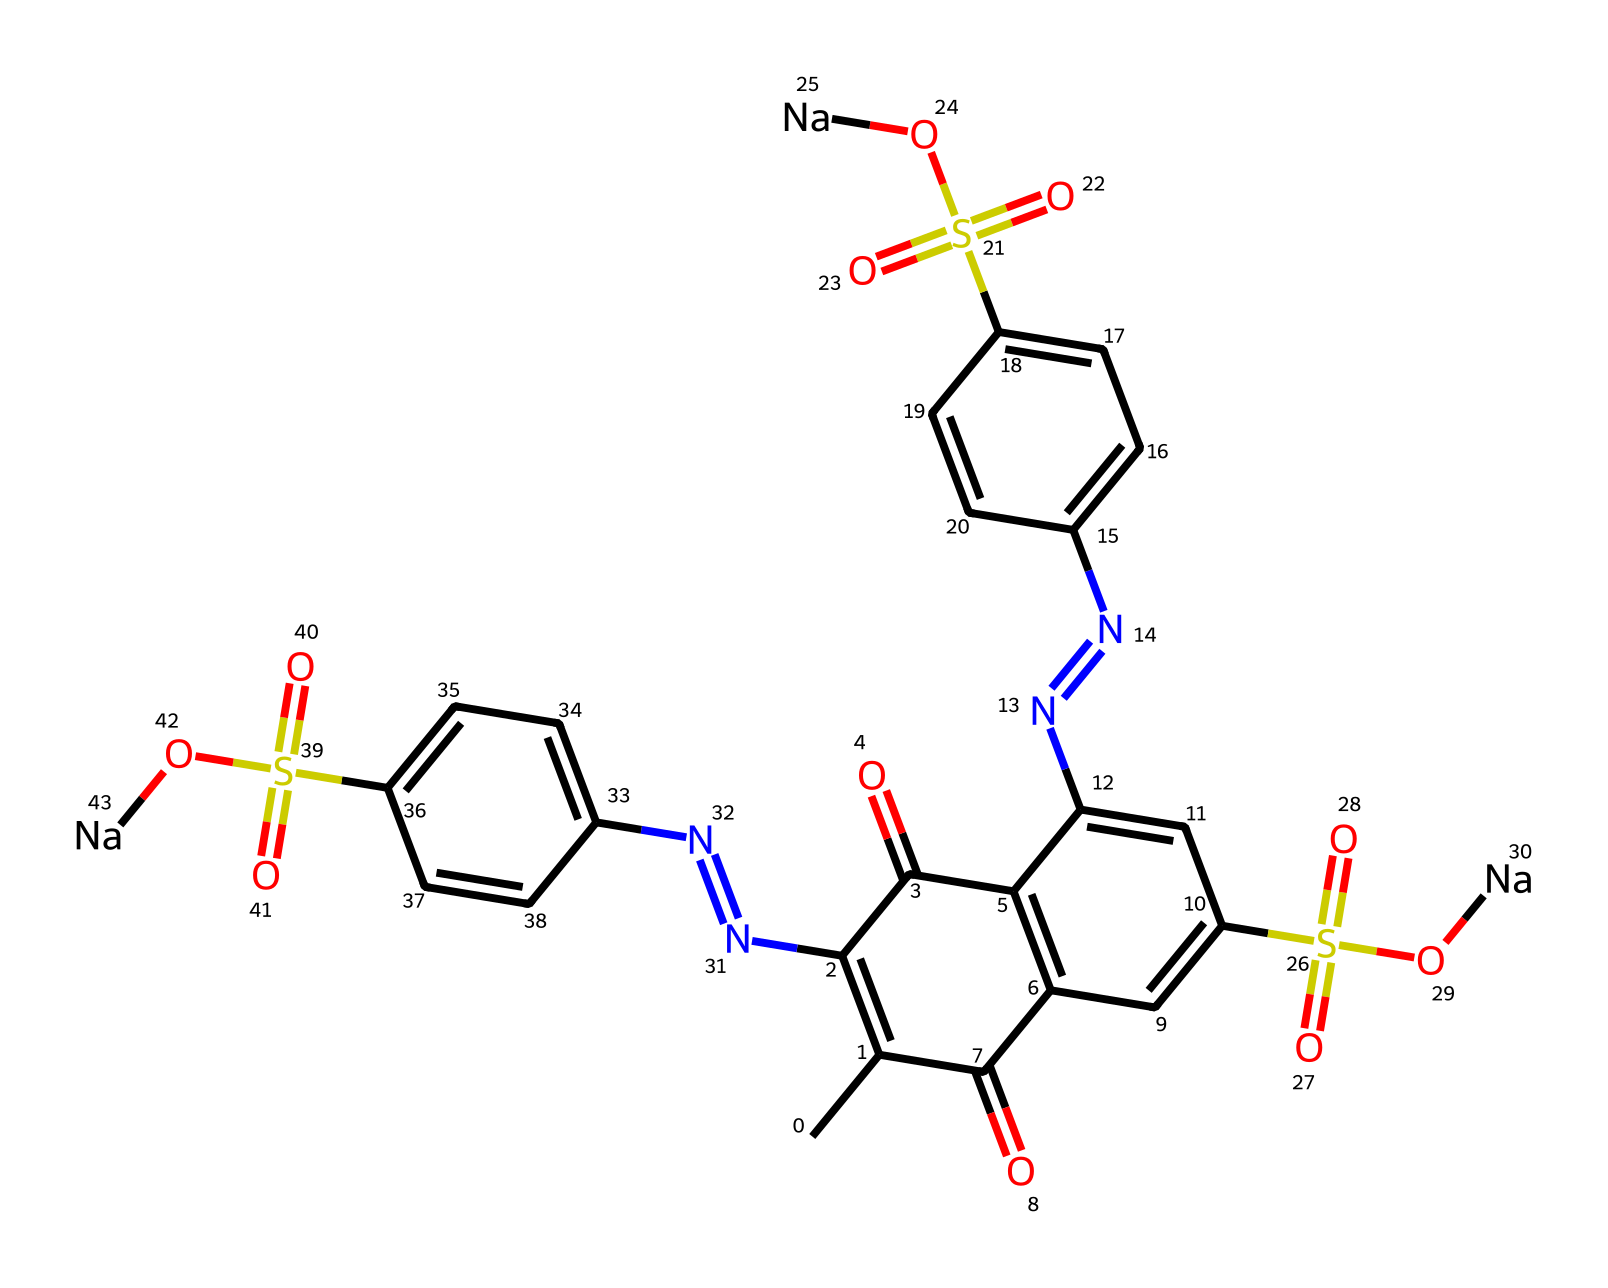What is the total number of carbon atoms in this chemical? By analyzing the SMILES representation, we identify that the structure contains 18 carbon atoms, which can be counted directly from the SMILES notation, considering each 'C' and the carbons in ring structures.
Answer: 18 How many nitrogen atoms are present in this molecule? The structure shows four nitrogen atoms, which are represented by 'N' in the SMILES. Carefully counting each nitrogen in the sequence reveals four instances.
Answer: 4 What is the molecular weight of this food coloring? The molecular weight can be calculated by summing the weights of all the constituent atoms based on their counts: 18 carbon (C), 4 nitrogen (N), 18 hydrogen (H), and 4 oxygen (O) atoms lead to a molecular weight of 486.
Answer: 486 Which functional groups can be identified in this chemical? Observing the structure, we see sulfonic acid groups (indicated by 'S(=O)(=O)O') and amine groups (the nitrogens connected in the structure). The presence of these functional groups provides insight into the chemical's properties and reactivity.
Answer: sulfonic acid and amine Is this a natural or synthetic food additive? The complexity of the structure and the presence of synthetic patterns in the SMILES representation suggest that this food coloring is typically synthetic, as natural food colorings are generally simpler in structure.
Answer: synthetic What is the role of the sulfonic acid groups in this food coloring? The sulfonic acid groups in the chemical contribute to its solubility in water, which is crucial for its effectiveness as a food dye. The increased polarity from these groups allows the food coloring to disperse evenly in aqueous solutions.
Answer: solubility 